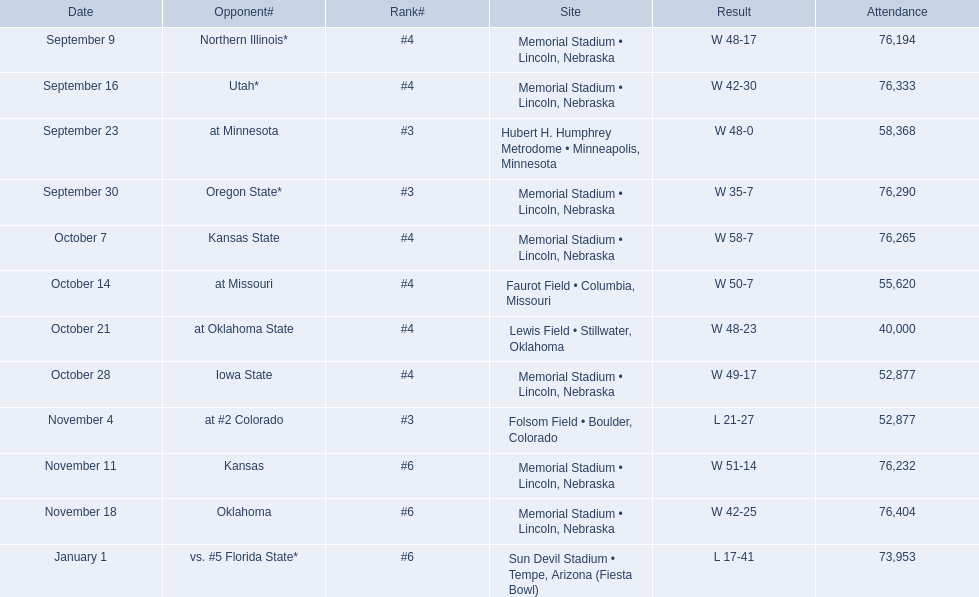Against which opponents did the nebraska cornhuskers score less than 40 points? Oregon State*, at #2 Colorado, vs. #5 Florida State*. In these matches, which ones had a crowd of over 70,000? Oregon State*, vs. #5 Florida State*. Which of these teams did they defeat? Oregon State*. What was the attendance figure for that specific game? 76,290. 